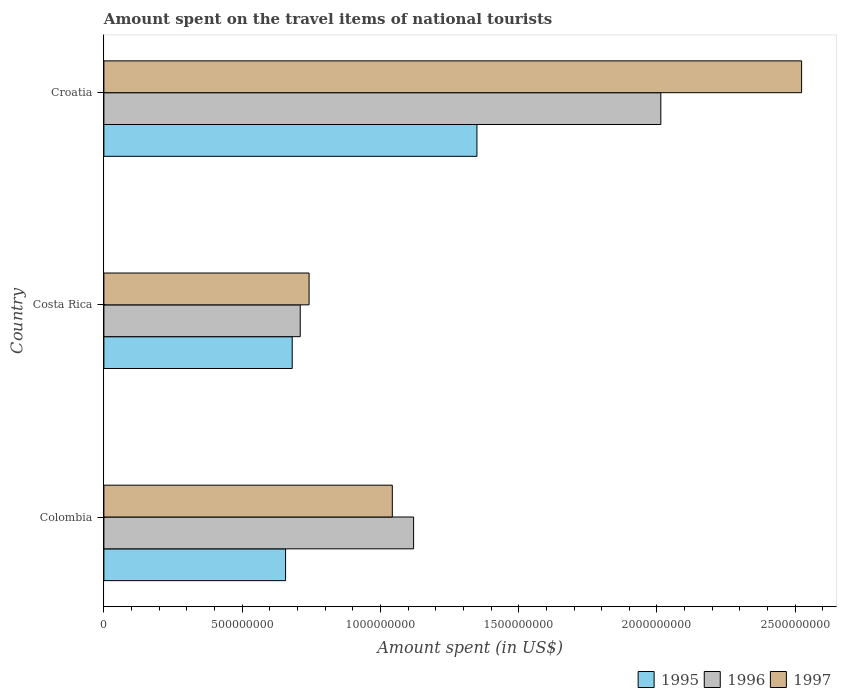How many groups of bars are there?
Offer a very short reply. 3. Are the number of bars per tick equal to the number of legend labels?
Provide a short and direct response. Yes. Are the number of bars on each tick of the Y-axis equal?
Ensure brevity in your answer.  Yes. How many bars are there on the 2nd tick from the top?
Ensure brevity in your answer.  3. How many bars are there on the 1st tick from the bottom?
Offer a terse response. 3. What is the label of the 1st group of bars from the top?
Your response must be concise. Croatia. What is the amount spent on the travel items of national tourists in 1995 in Colombia?
Give a very brief answer. 6.57e+08. Across all countries, what is the maximum amount spent on the travel items of national tourists in 1996?
Your answer should be compact. 2.01e+09. Across all countries, what is the minimum amount spent on the travel items of national tourists in 1996?
Provide a succinct answer. 7.10e+08. In which country was the amount spent on the travel items of national tourists in 1995 maximum?
Keep it short and to the point. Croatia. What is the total amount spent on the travel items of national tourists in 1995 in the graph?
Provide a succinct answer. 2.69e+09. What is the difference between the amount spent on the travel items of national tourists in 1996 in Costa Rica and that in Croatia?
Provide a succinct answer. -1.30e+09. What is the difference between the amount spent on the travel items of national tourists in 1995 in Croatia and the amount spent on the travel items of national tourists in 1996 in Colombia?
Make the answer very short. 2.29e+08. What is the average amount spent on the travel items of national tourists in 1995 per country?
Ensure brevity in your answer.  8.96e+08. What is the difference between the amount spent on the travel items of national tourists in 1996 and amount spent on the travel items of national tourists in 1995 in Croatia?
Your answer should be compact. 6.65e+08. What is the ratio of the amount spent on the travel items of national tourists in 1996 in Colombia to that in Croatia?
Offer a terse response. 0.56. What is the difference between the highest and the second highest amount spent on the travel items of national tourists in 1997?
Ensure brevity in your answer.  1.48e+09. What is the difference between the highest and the lowest amount spent on the travel items of national tourists in 1997?
Offer a very short reply. 1.78e+09. Is the sum of the amount spent on the travel items of national tourists in 1995 in Colombia and Costa Rica greater than the maximum amount spent on the travel items of national tourists in 1996 across all countries?
Keep it short and to the point. No. What does the 3rd bar from the top in Croatia represents?
Your answer should be very brief. 1995. Is it the case that in every country, the sum of the amount spent on the travel items of national tourists in 1997 and amount spent on the travel items of national tourists in 1996 is greater than the amount spent on the travel items of national tourists in 1995?
Your answer should be compact. Yes. Are all the bars in the graph horizontal?
Your answer should be compact. Yes. How many countries are there in the graph?
Provide a short and direct response. 3. Are the values on the major ticks of X-axis written in scientific E-notation?
Your answer should be compact. No. Does the graph contain any zero values?
Your answer should be very brief. No. Where does the legend appear in the graph?
Your answer should be compact. Bottom right. How are the legend labels stacked?
Your response must be concise. Horizontal. What is the title of the graph?
Give a very brief answer. Amount spent on the travel items of national tourists. What is the label or title of the X-axis?
Your answer should be very brief. Amount spent (in US$). What is the label or title of the Y-axis?
Offer a terse response. Country. What is the Amount spent (in US$) of 1995 in Colombia?
Offer a very short reply. 6.57e+08. What is the Amount spent (in US$) in 1996 in Colombia?
Your answer should be compact. 1.12e+09. What is the Amount spent (in US$) in 1997 in Colombia?
Make the answer very short. 1.04e+09. What is the Amount spent (in US$) of 1995 in Costa Rica?
Your answer should be compact. 6.81e+08. What is the Amount spent (in US$) of 1996 in Costa Rica?
Your answer should be compact. 7.10e+08. What is the Amount spent (in US$) of 1997 in Costa Rica?
Your answer should be compact. 7.42e+08. What is the Amount spent (in US$) in 1995 in Croatia?
Provide a short and direct response. 1.35e+09. What is the Amount spent (in US$) in 1996 in Croatia?
Provide a succinct answer. 2.01e+09. What is the Amount spent (in US$) in 1997 in Croatia?
Make the answer very short. 2.52e+09. Across all countries, what is the maximum Amount spent (in US$) of 1995?
Provide a short and direct response. 1.35e+09. Across all countries, what is the maximum Amount spent (in US$) of 1996?
Your answer should be very brief. 2.01e+09. Across all countries, what is the maximum Amount spent (in US$) in 1997?
Offer a terse response. 2.52e+09. Across all countries, what is the minimum Amount spent (in US$) of 1995?
Give a very brief answer. 6.57e+08. Across all countries, what is the minimum Amount spent (in US$) in 1996?
Make the answer very short. 7.10e+08. Across all countries, what is the minimum Amount spent (in US$) in 1997?
Keep it short and to the point. 7.42e+08. What is the total Amount spent (in US$) of 1995 in the graph?
Keep it short and to the point. 2.69e+09. What is the total Amount spent (in US$) in 1996 in the graph?
Offer a terse response. 3.84e+09. What is the total Amount spent (in US$) in 1997 in the graph?
Provide a short and direct response. 4.31e+09. What is the difference between the Amount spent (in US$) of 1995 in Colombia and that in Costa Rica?
Your response must be concise. -2.40e+07. What is the difference between the Amount spent (in US$) of 1996 in Colombia and that in Costa Rica?
Your answer should be compact. 4.10e+08. What is the difference between the Amount spent (in US$) in 1997 in Colombia and that in Costa Rica?
Give a very brief answer. 3.01e+08. What is the difference between the Amount spent (in US$) in 1995 in Colombia and that in Croatia?
Ensure brevity in your answer.  -6.92e+08. What is the difference between the Amount spent (in US$) of 1996 in Colombia and that in Croatia?
Give a very brief answer. -8.94e+08. What is the difference between the Amount spent (in US$) of 1997 in Colombia and that in Croatia?
Offer a very short reply. -1.48e+09. What is the difference between the Amount spent (in US$) in 1995 in Costa Rica and that in Croatia?
Offer a terse response. -6.68e+08. What is the difference between the Amount spent (in US$) of 1996 in Costa Rica and that in Croatia?
Provide a short and direct response. -1.30e+09. What is the difference between the Amount spent (in US$) of 1997 in Costa Rica and that in Croatia?
Your answer should be very brief. -1.78e+09. What is the difference between the Amount spent (in US$) of 1995 in Colombia and the Amount spent (in US$) of 1996 in Costa Rica?
Ensure brevity in your answer.  -5.30e+07. What is the difference between the Amount spent (in US$) of 1995 in Colombia and the Amount spent (in US$) of 1997 in Costa Rica?
Keep it short and to the point. -8.50e+07. What is the difference between the Amount spent (in US$) of 1996 in Colombia and the Amount spent (in US$) of 1997 in Costa Rica?
Ensure brevity in your answer.  3.78e+08. What is the difference between the Amount spent (in US$) in 1995 in Colombia and the Amount spent (in US$) in 1996 in Croatia?
Your answer should be compact. -1.36e+09. What is the difference between the Amount spent (in US$) of 1995 in Colombia and the Amount spent (in US$) of 1997 in Croatia?
Your response must be concise. -1.87e+09. What is the difference between the Amount spent (in US$) in 1996 in Colombia and the Amount spent (in US$) in 1997 in Croatia?
Your response must be concise. -1.40e+09. What is the difference between the Amount spent (in US$) of 1995 in Costa Rica and the Amount spent (in US$) of 1996 in Croatia?
Your answer should be compact. -1.33e+09. What is the difference between the Amount spent (in US$) of 1995 in Costa Rica and the Amount spent (in US$) of 1997 in Croatia?
Provide a succinct answer. -1.84e+09. What is the difference between the Amount spent (in US$) of 1996 in Costa Rica and the Amount spent (in US$) of 1997 in Croatia?
Ensure brevity in your answer.  -1.81e+09. What is the average Amount spent (in US$) of 1995 per country?
Give a very brief answer. 8.96e+08. What is the average Amount spent (in US$) of 1996 per country?
Your answer should be compact. 1.28e+09. What is the average Amount spent (in US$) of 1997 per country?
Ensure brevity in your answer.  1.44e+09. What is the difference between the Amount spent (in US$) of 1995 and Amount spent (in US$) of 1996 in Colombia?
Offer a very short reply. -4.63e+08. What is the difference between the Amount spent (in US$) in 1995 and Amount spent (in US$) in 1997 in Colombia?
Offer a terse response. -3.86e+08. What is the difference between the Amount spent (in US$) of 1996 and Amount spent (in US$) of 1997 in Colombia?
Your response must be concise. 7.70e+07. What is the difference between the Amount spent (in US$) of 1995 and Amount spent (in US$) of 1996 in Costa Rica?
Your response must be concise. -2.90e+07. What is the difference between the Amount spent (in US$) in 1995 and Amount spent (in US$) in 1997 in Costa Rica?
Make the answer very short. -6.10e+07. What is the difference between the Amount spent (in US$) in 1996 and Amount spent (in US$) in 1997 in Costa Rica?
Provide a short and direct response. -3.20e+07. What is the difference between the Amount spent (in US$) of 1995 and Amount spent (in US$) of 1996 in Croatia?
Your response must be concise. -6.65e+08. What is the difference between the Amount spent (in US$) of 1995 and Amount spent (in US$) of 1997 in Croatia?
Your answer should be very brief. -1.17e+09. What is the difference between the Amount spent (in US$) in 1996 and Amount spent (in US$) in 1997 in Croatia?
Give a very brief answer. -5.09e+08. What is the ratio of the Amount spent (in US$) in 1995 in Colombia to that in Costa Rica?
Provide a short and direct response. 0.96. What is the ratio of the Amount spent (in US$) in 1996 in Colombia to that in Costa Rica?
Give a very brief answer. 1.58. What is the ratio of the Amount spent (in US$) in 1997 in Colombia to that in Costa Rica?
Provide a short and direct response. 1.41. What is the ratio of the Amount spent (in US$) of 1995 in Colombia to that in Croatia?
Make the answer very short. 0.49. What is the ratio of the Amount spent (in US$) of 1996 in Colombia to that in Croatia?
Your response must be concise. 0.56. What is the ratio of the Amount spent (in US$) in 1997 in Colombia to that in Croatia?
Offer a very short reply. 0.41. What is the ratio of the Amount spent (in US$) of 1995 in Costa Rica to that in Croatia?
Your answer should be very brief. 0.5. What is the ratio of the Amount spent (in US$) in 1996 in Costa Rica to that in Croatia?
Keep it short and to the point. 0.35. What is the ratio of the Amount spent (in US$) in 1997 in Costa Rica to that in Croatia?
Your response must be concise. 0.29. What is the difference between the highest and the second highest Amount spent (in US$) in 1995?
Give a very brief answer. 6.68e+08. What is the difference between the highest and the second highest Amount spent (in US$) of 1996?
Provide a short and direct response. 8.94e+08. What is the difference between the highest and the second highest Amount spent (in US$) of 1997?
Make the answer very short. 1.48e+09. What is the difference between the highest and the lowest Amount spent (in US$) in 1995?
Provide a short and direct response. 6.92e+08. What is the difference between the highest and the lowest Amount spent (in US$) in 1996?
Provide a short and direct response. 1.30e+09. What is the difference between the highest and the lowest Amount spent (in US$) of 1997?
Provide a short and direct response. 1.78e+09. 